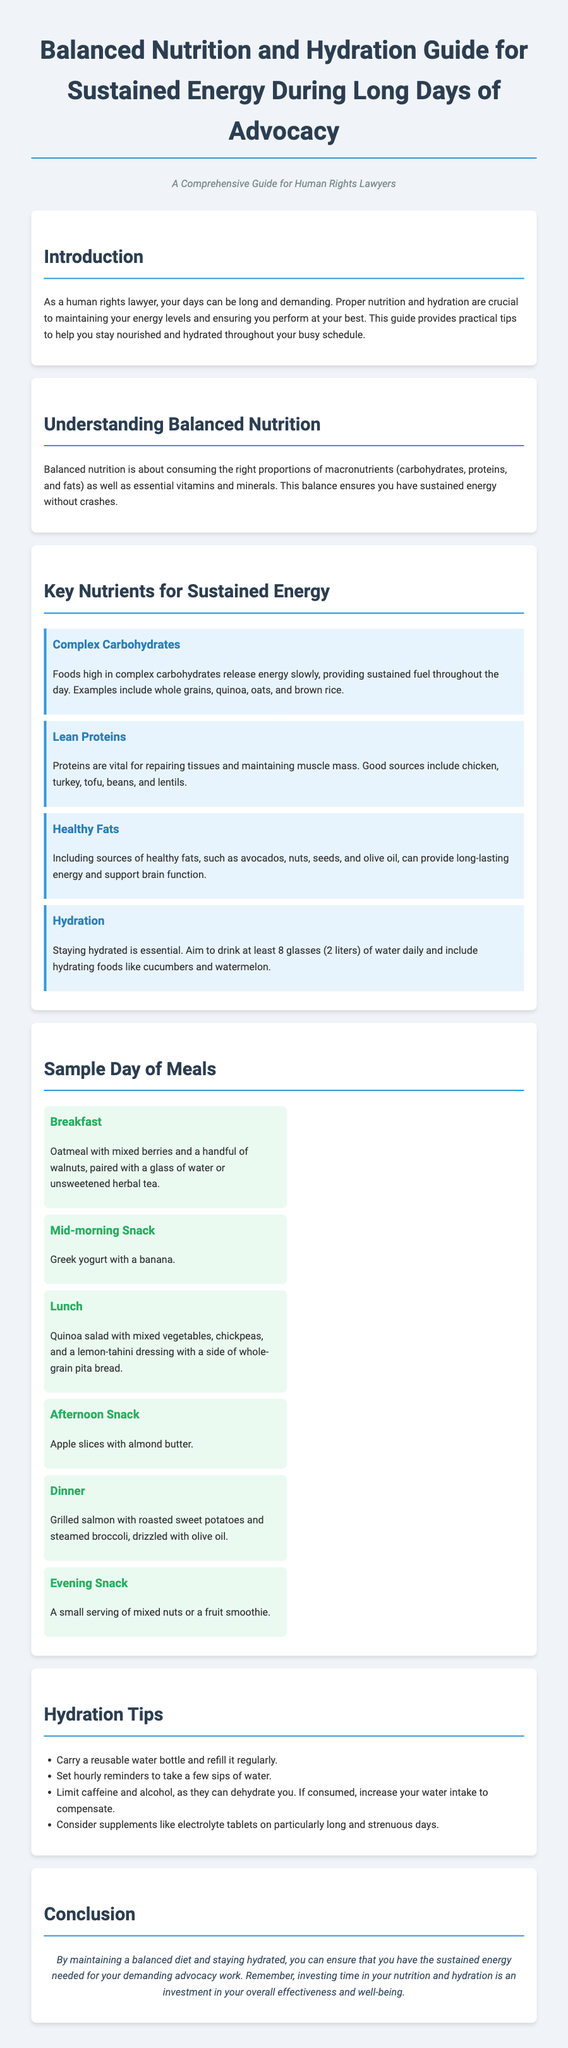What is the main purpose of the guide? The introduction states that the guide provides practical tips for nutrition and hydration to help maintain energy levels during demanding work.
Answer: Maintaining energy levels How many glasses of water should be consumed daily? The hydration section specifies that one should drink at least 8 glasses of water daily.
Answer: 8 glasses What type of fats are recommended for sustained energy? The section on key nutrients mentions including sources of healthy fats for long-lasting energy.
Answer: Healthy fats List one example of a complex carbohydrate. The guide provides examples of complex carbohydrates, one of which is whole grains.
Answer: Whole grains What is a recommended evening snack? The sample meal plan suggests a small serving of mixed nuts or a fruit smoothie as an evening snack.
Answer: Mixed nuts or a fruit smoothie Why is hydration important? The document emphasizes the necessity of hydration for maintaining energy and performance during long days.
Answer: Maintaining energy and performance What type of proteins should be included in meals? The guide identifies lean proteins as essential for repairing tissues and maintaining muscle mass.
Answer: Lean proteins What should be included in a mid-morning snack? The meal plan specifies Greek yogurt with a banana as a mid-morning snack.
Answer: Greek yogurt with a banana How can hydration be enhanced on strenuous days? The hydration tips suggest considering supplements like electrolyte tablets on long and strenuous days.
Answer: Electrolyte tablets 